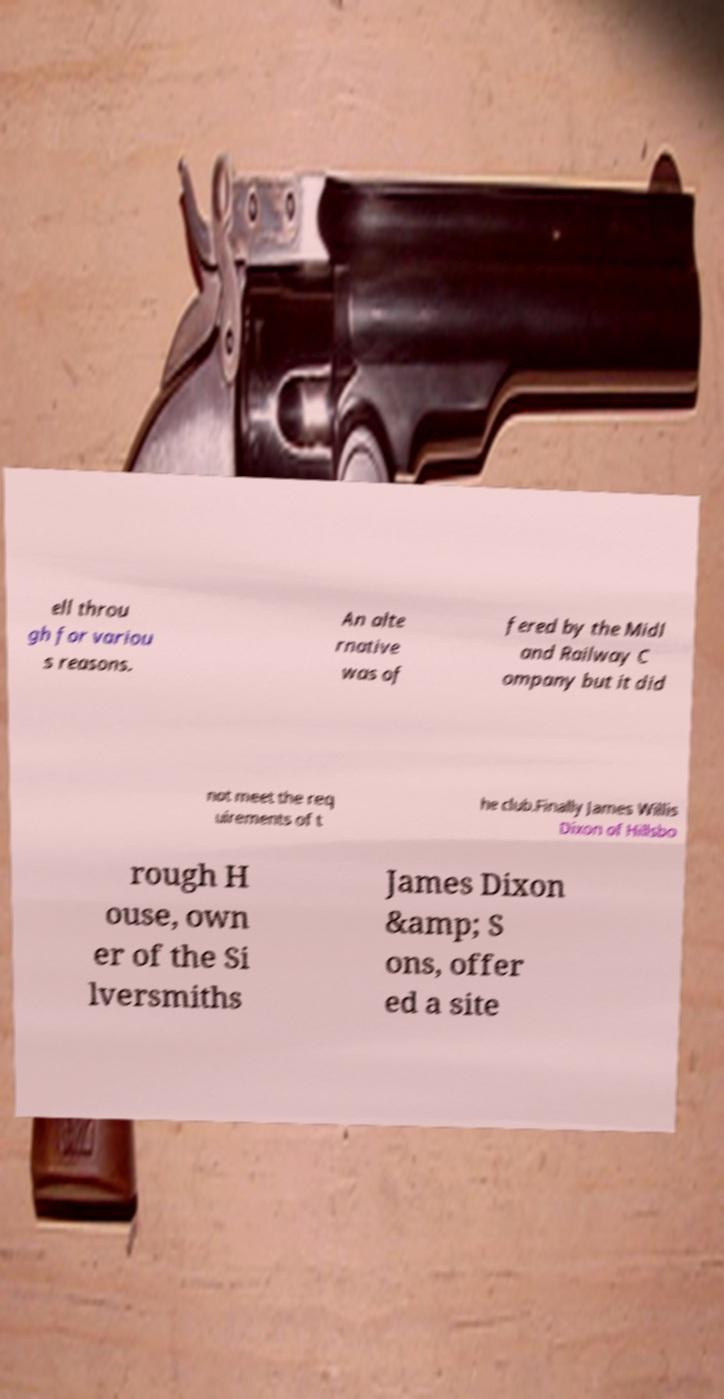Please identify and transcribe the text found in this image. ell throu gh for variou s reasons. An alte rnative was of fered by the Midl and Railway C ompany but it did not meet the req uirements of t he club.Finally James Willis Dixon of Hillsbo rough H ouse, own er of the Si lversmiths James Dixon &amp; S ons, offer ed a site 